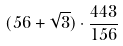Convert formula to latex. <formula><loc_0><loc_0><loc_500><loc_500>( 5 6 + \sqrt { 3 } ) \cdot \frac { 4 4 3 } { 1 5 6 }</formula> 